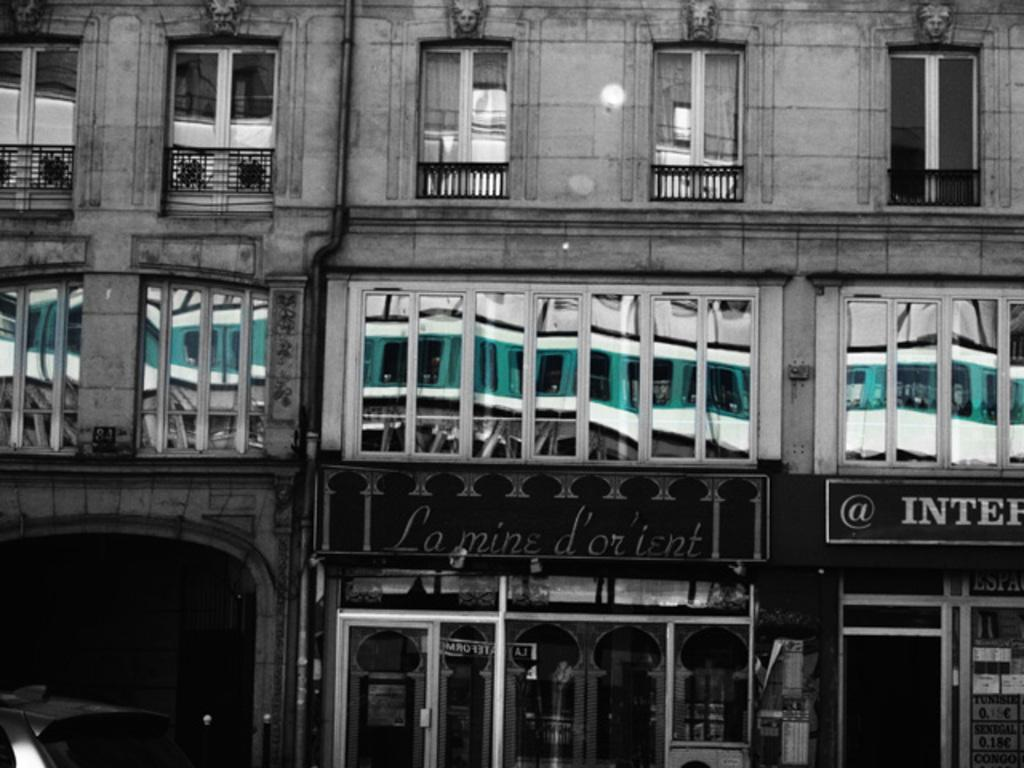What type of structure is visible in the image? There is a building in the image. What objects can be seen near the building? There are glasses visible in the image. What is located at the bottom of the image? There is a board at the bottom of the image. What information is provided on the board? There is text on the board. How does the earthquake affect the building in the image? There is no earthquake present in the image, so its effects cannot be observed. 